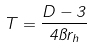<formula> <loc_0><loc_0><loc_500><loc_500>T = \frac { D - 3 } { 4 \pi r _ { h } }</formula> 